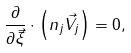Convert formula to latex. <formula><loc_0><loc_0><loc_500><loc_500>\frac { \partial } { \partial { \vec { \xi } } } \cdot \left ( n _ { j } \vec { V } _ { j } \right ) = 0 ,</formula> 